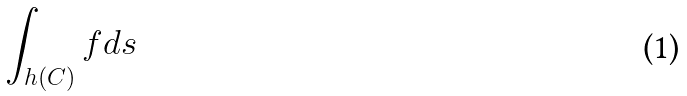<formula> <loc_0><loc_0><loc_500><loc_500>\int _ { h ( C ) } f d s</formula> 